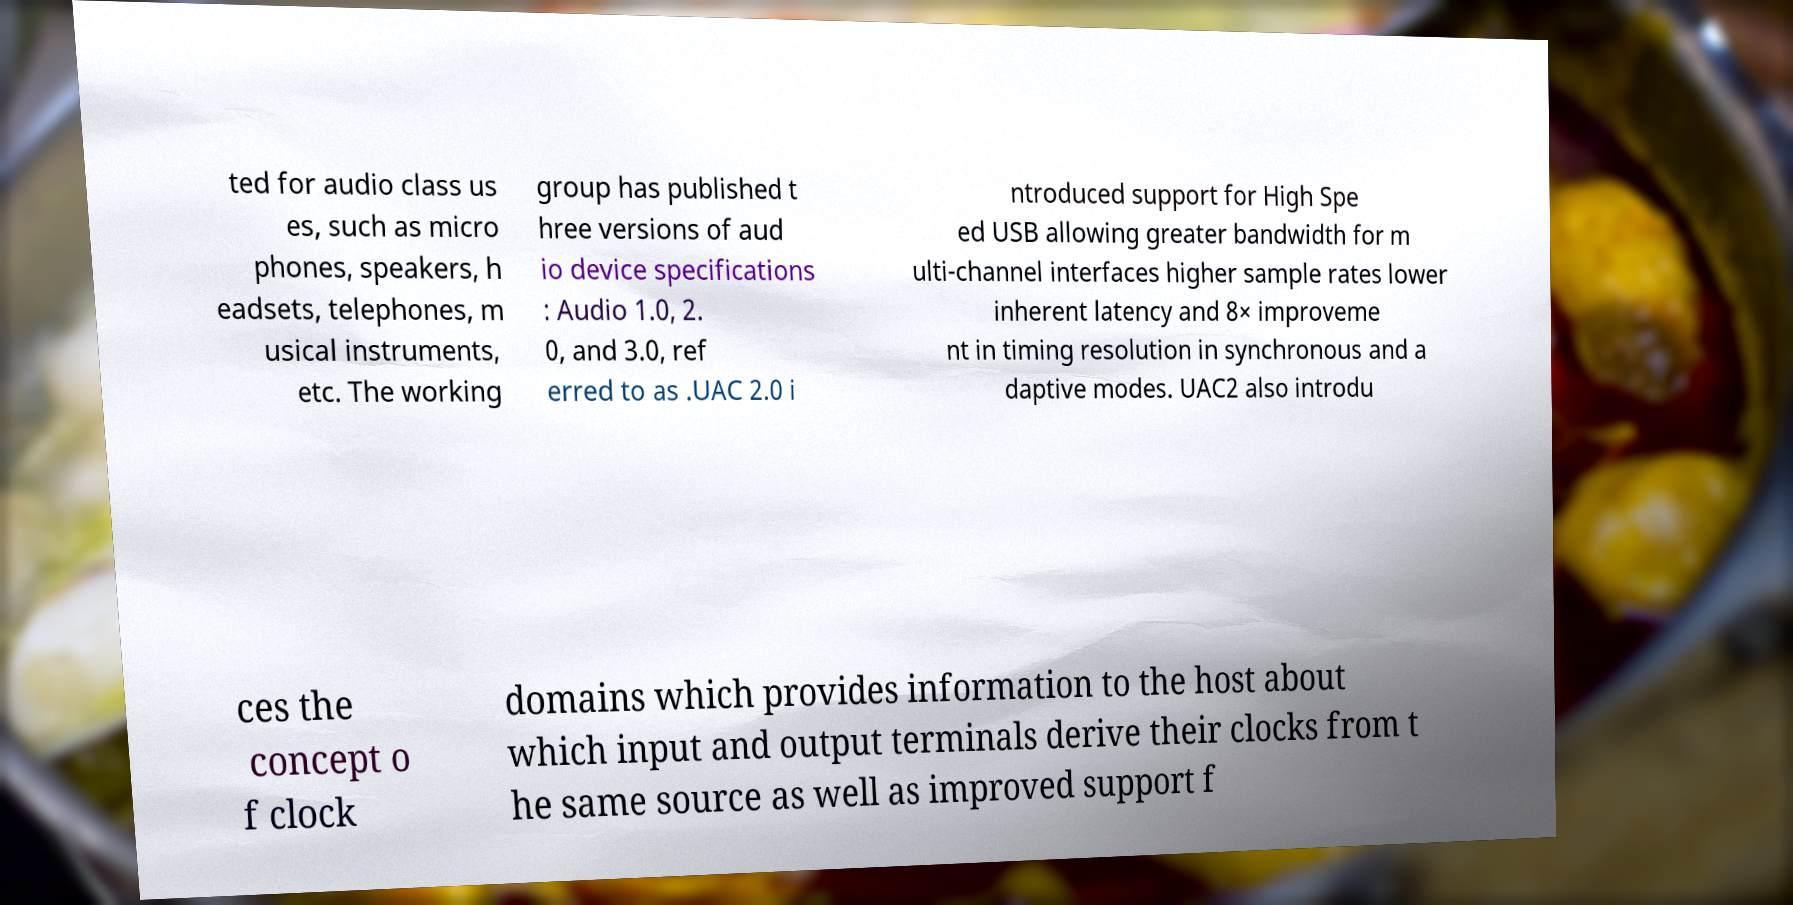There's text embedded in this image that I need extracted. Can you transcribe it verbatim? ted for audio class us es, such as micro phones, speakers, h eadsets, telephones, m usical instruments, etc. The working group has published t hree versions of aud io device specifications : Audio 1.0, 2. 0, and 3.0, ref erred to as .UAC 2.0 i ntroduced support for High Spe ed USB allowing greater bandwidth for m ulti-channel interfaces higher sample rates lower inherent latency and 8× improveme nt in timing resolution in synchronous and a daptive modes. UAC2 also introdu ces the concept o f clock domains which provides information to the host about which input and output terminals derive their clocks from t he same source as well as improved support f 